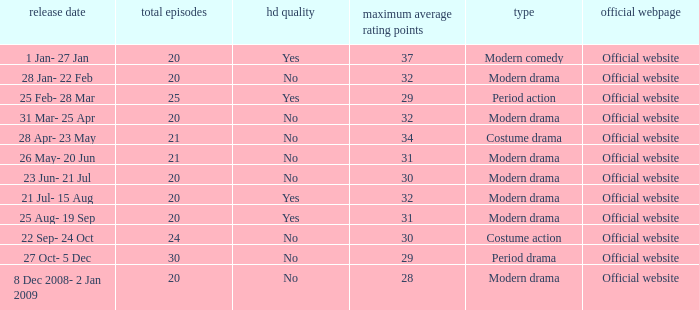What was the airing date when the number of episodes was larger than 20 and had the genre of costume action? 22 Sep- 24 Oct. 